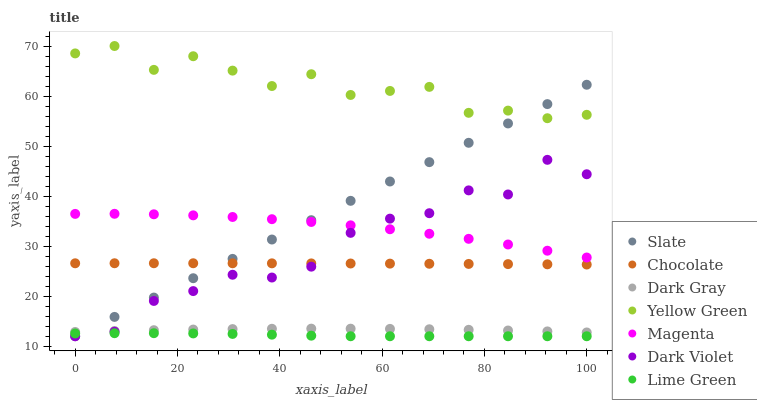Does Lime Green have the minimum area under the curve?
Answer yes or no. Yes. Does Yellow Green have the maximum area under the curve?
Answer yes or no. Yes. Does Slate have the minimum area under the curve?
Answer yes or no. No. Does Slate have the maximum area under the curve?
Answer yes or no. No. Is Slate the smoothest?
Answer yes or no. Yes. Is Dark Violet the roughest?
Answer yes or no. Yes. Is Dark Violet the smoothest?
Answer yes or no. No. Is Slate the roughest?
Answer yes or no. No. Does Slate have the lowest value?
Answer yes or no. Yes. Does Chocolate have the lowest value?
Answer yes or no. No. Does Yellow Green have the highest value?
Answer yes or no. Yes. Does Slate have the highest value?
Answer yes or no. No. Is Magenta less than Yellow Green?
Answer yes or no. Yes. Is Yellow Green greater than Magenta?
Answer yes or no. Yes. Does Lime Green intersect Slate?
Answer yes or no. Yes. Is Lime Green less than Slate?
Answer yes or no. No. Is Lime Green greater than Slate?
Answer yes or no. No. Does Magenta intersect Yellow Green?
Answer yes or no. No. 